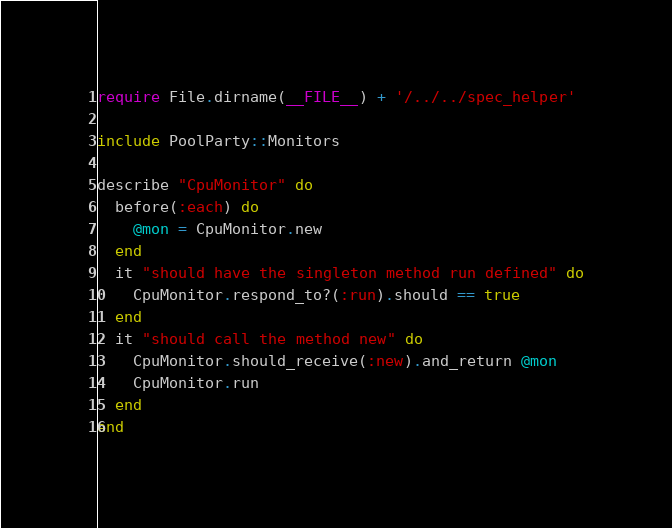Convert code to text. <code><loc_0><loc_0><loc_500><loc_500><_Ruby_>require File.dirname(__FILE__) + '/../../spec_helper'

include PoolParty::Monitors

describe "CpuMonitor" do
  before(:each) do
    @mon = CpuMonitor.new
  end
  it "should have the singleton method run defined" do
    CpuMonitor.respond_to?(:run).should == true
  end
  it "should call the method new" do
    CpuMonitor.should_receive(:new).and_return @mon
    CpuMonitor.run
  end
end</code> 